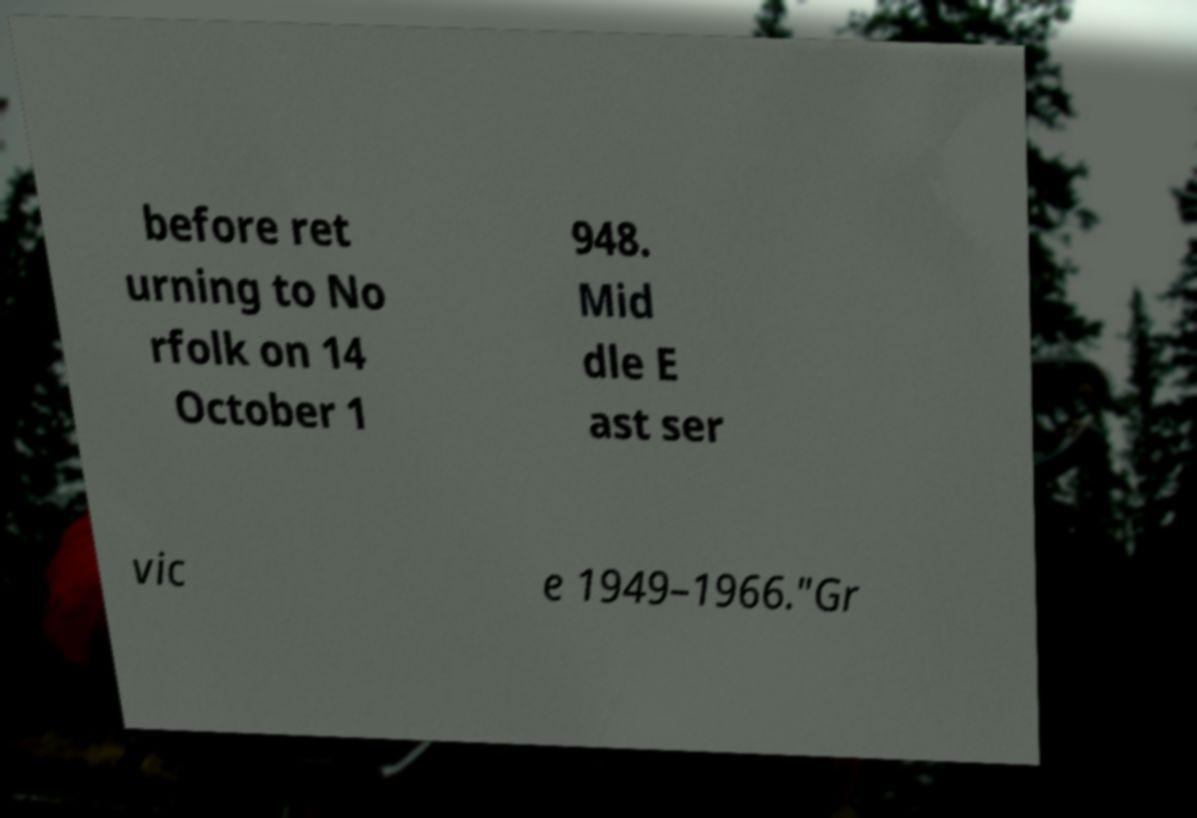Can you read and provide the text displayed in the image?This photo seems to have some interesting text. Can you extract and type it out for me? before ret urning to No rfolk on 14 October 1 948. Mid dle E ast ser vic e 1949–1966."Gr 